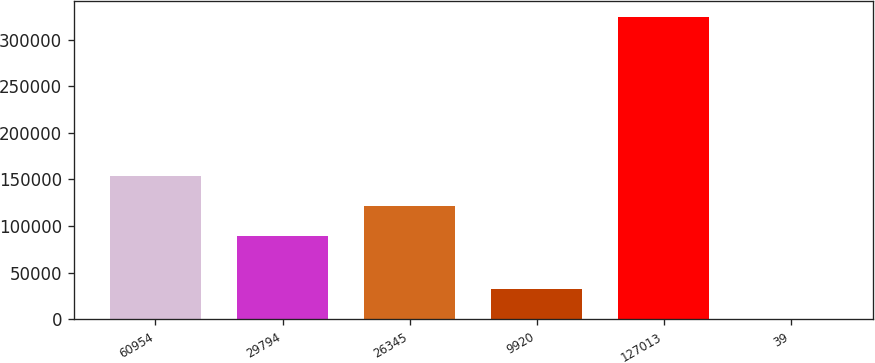Convert chart to OTSL. <chart><loc_0><loc_0><loc_500><loc_500><bar_chart><fcel>60954<fcel>29794<fcel>26345<fcel>9920<fcel>127013<fcel>39<nl><fcel>153723<fcel>88782<fcel>121253<fcel>32570.6<fcel>324806<fcel>100<nl></chart> 